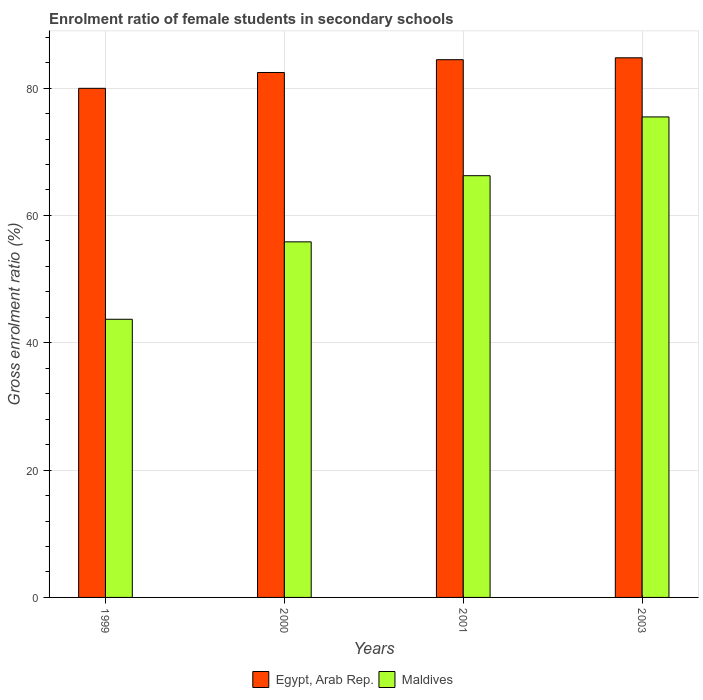How many bars are there on the 2nd tick from the left?
Give a very brief answer. 2. How many bars are there on the 3rd tick from the right?
Give a very brief answer. 2. What is the label of the 1st group of bars from the left?
Give a very brief answer. 1999. In how many cases, is the number of bars for a given year not equal to the number of legend labels?
Give a very brief answer. 0. What is the enrolment ratio of female students in secondary schools in Egypt, Arab Rep. in 2003?
Provide a succinct answer. 84.75. Across all years, what is the maximum enrolment ratio of female students in secondary schools in Maldives?
Keep it short and to the point. 75.47. Across all years, what is the minimum enrolment ratio of female students in secondary schools in Maldives?
Offer a terse response. 43.69. In which year was the enrolment ratio of female students in secondary schools in Maldives maximum?
Make the answer very short. 2003. What is the total enrolment ratio of female students in secondary schools in Maldives in the graph?
Offer a very short reply. 241.24. What is the difference between the enrolment ratio of female students in secondary schools in Egypt, Arab Rep. in 1999 and that in 2000?
Your answer should be compact. -2.48. What is the difference between the enrolment ratio of female students in secondary schools in Maldives in 2003 and the enrolment ratio of female students in secondary schools in Egypt, Arab Rep. in 1999?
Provide a short and direct response. -4.49. What is the average enrolment ratio of female students in secondary schools in Egypt, Arab Rep. per year?
Your response must be concise. 82.91. In the year 2003, what is the difference between the enrolment ratio of female students in secondary schools in Egypt, Arab Rep. and enrolment ratio of female students in secondary schools in Maldives?
Your answer should be compact. 9.29. What is the ratio of the enrolment ratio of female students in secondary schools in Egypt, Arab Rep. in 1999 to that in 2001?
Offer a very short reply. 0.95. Is the enrolment ratio of female students in secondary schools in Maldives in 2001 less than that in 2003?
Ensure brevity in your answer.  Yes. Is the difference between the enrolment ratio of female students in secondary schools in Egypt, Arab Rep. in 2000 and 2003 greater than the difference between the enrolment ratio of female students in secondary schools in Maldives in 2000 and 2003?
Keep it short and to the point. Yes. What is the difference between the highest and the second highest enrolment ratio of female students in secondary schools in Egypt, Arab Rep.?
Offer a very short reply. 0.3. What is the difference between the highest and the lowest enrolment ratio of female students in secondary schools in Maldives?
Offer a terse response. 31.78. Is the sum of the enrolment ratio of female students in secondary schools in Egypt, Arab Rep. in 2000 and 2001 greater than the maximum enrolment ratio of female students in secondary schools in Maldives across all years?
Keep it short and to the point. Yes. What does the 1st bar from the left in 1999 represents?
Make the answer very short. Egypt, Arab Rep. What does the 1st bar from the right in 2003 represents?
Provide a succinct answer. Maldives. Are all the bars in the graph horizontal?
Offer a very short reply. No. How many years are there in the graph?
Offer a terse response. 4. What is the difference between two consecutive major ticks on the Y-axis?
Provide a short and direct response. 20. Where does the legend appear in the graph?
Offer a very short reply. Bottom center. How many legend labels are there?
Your response must be concise. 2. How are the legend labels stacked?
Make the answer very short. Horizontal. What is the title of the graph?
Keep it short and to the point. Enrolment ratio of female students in secondary schools. What is the Gross enrolment ratio (%) in Egypt, Arab Rep. in 1999?
Your answer should be very brief. 79.96. What is the Gross enrolment ratio (%) in Maldives in 1999?
Ensure brevity in your answer.  43.69. What is the Gross enrolment ratio (%) in Egypt, Arab Rep. in 2000?
Your answer should be very brief. 82.45. What is the Gross enrolment ratio (%) of Maldives in 2000?
Provide a short and direct response. 55.85. What is the Gross enrolment ratio (%) of Egypt, Arab Rep. in 2001?
Your answer should be very brief. 84.46. What is the Gross enrolment ratio (%) of Maldives in 2001?
Make the answer very short. 66.24. What is the Gross enrolment ratio (%) in Egypt, Arab Rep. in 2003?
Provide a succinct answer. 84.75. What is the Gross enrolment ratio (%) in Maldives in 2003?
Your response must be concise. 75.47. Across all years, what is the maximum Gross enrolment ratio (%) of Egypt, Arab Rep.?
Give a very brief answer. 84.75. Across all years, what is the maximum Gross enrolment ratio (%) of Maldives?
Keep it short and to the point. 75.47. Across all years, what is the minimum Gross enrolment ratio (%) of Egypt, Arab Rep.?
Offer a very short reply. 79.96. Across all years, what is the minimum Gross enrolment ratio (%) in Maldives?
Give a very brief answer. 43.69. What is the total Gross enrolment ratio (%) in Egypt, Arab Rep. in the graph?
Provide a succinct answer. 331.62. What is the total Gross enrolment ratio (%) in Maldives in the graph?
Keep it short and to the point. 241.24. What is the difference between the Gross enrolment ratio (%) in Egypt, Arab Rep. in 1999 and that in 2000?
Your response must be concise. -2.48. What is the difference between the Gross enrolment ratio (%) in Maldives in 1999 and that in 2000?
Offer a very short reply. -12.16. What is the difference between the Gross enrolment ratio (%) in Egypt, Arab Rep. in 1999 and that in 2001?
Give a very brief answer. -4.49. What is the difference between the Gross enrolment ratio (%) of Maldives in 1999 and that in 2001?
Your answer should be compact. -22.55. What is the difference between the Gross enrolment ratio (%) of Egypt, Arab Rep. in 1999 and that in 2003?
Keep it short and to the point. -4.79. What is the difference between the Gross enrolment ratio (%) of Maldives in 1999 and that in 2003?
Your answer should be compact. -31.78. What is the difference between the Gross enrolment ratio (%) in Egypt, Arab Rep. in 2000 and that in 2001?
Your answer should be very brief. -2.01. What is the difference between the Gross enrolment ratio (%) in Maldives in 2000 and that in 2001?
Your response must be concise. -10.39. What is the difference between the Gross enrolment ratio (%) of Egypt, Arab Rep. in 2000 and that in 2003?
Your answer should be compact. -2.31. What is the difference between the Gross enrolment ratio (%) in Maldives in 2000 and that in 2003?
Give a very brief answer. -19.62. What is the difference between the Gross enrolment ratio (%) of Egypt, Arab Rep. in 2001 and that in 2003?
Provide a short and direct response. -0.3. What is the difference between the Gross enrolment ratio (%) of Maldives in 2001 and that in 2003?
Ensure brevity in your answer.  -9.23. What is the difference between the Gross enrolment ratio (%) in Egypt, Arab Rep. in 1999 and the Gross enrolment ratio (%) in Maldives in 2000?
Give a very brief answer. 24.11. What is the difference between the Gross enrolment ratio (%) of Egypt, Arab Rep. in 1999 and the Gross enrolment ratio (%) of Maldives in 2001?
Provide a succinct answer. 13.73. What is the difference between the Gross enrolment ratio (%) of Egypt, Arab Rep. in 1999 and the Gross enrolment ratio (%) of Maldives in 2003?
Offer a terse response. 4.49. What is the difference between the Gross enrolment ratio (%) of Egypt, Arab Rep. in 2000 and the Gross enrolment ratio (%) of Maldives in 2001?
Provide a succinct answer. 16.21. What is the difference between the Gross enrolment ratio (%) of Egypt, Arab Rep. in 2000 and the Gross enrolment ratio (%) of Maldives in 2003?
Offer a terse response. 6.98. What is the difference between the Gross enrolment ratio (%) of Egypt, Arab Rep. in 2001 and the Gross enrolment ratio (%) of Maldives in 2003?
Ensure brevity in your answer.  8.99. What is the average Gross enrolment ratio (%) in Egypt, Arab Rep. per year?
Your response must be concise. 82.91. What is the average Gross enrolment ratio (%) of Maldives per year?
Provide a succinct answer. 60.31. In the year 1999, what is the difference between the Gross enrolment ratio (%) in Egypt, Arab Rep. and Gross enrolment ratio (%) in Maldives?
Offer a terse response. 36.28. In the year 2000, what is the difference between the Gross enrolment ratio (%) in Egypt, Arab Rep. and Gross enrolment ratio (%) in Maldives?
Give a very brief answer. 26.6. In the year 2001, what is the difference between the Gross enrolment ratio (%) of Egypt, Arab Rep. and Gross enrolment ratio (%) of Maldives?
Keep it short and to the point. 18.22. In the year 2003, what is the difference between the Gross enrolment ratio (%) in Egypt, Arab Rep. and Gross enrolment ratio (%) in Maldives?
Keep it short and to the point. 9.29. What is the ratio of the Gross enrolment ratio (%) in Egypt, Arab Rep. in 1999 to that in 2000?
Ensure brevity in your answer.  0.97. What is the ratio of the Gross enrolment ratio (%) of Maldives in 1999 to that in 2000?
Make the answer very short. 0.78. What is the ratio of the Gross enrolment ratio (%) in Egypt, Arab Rep. in 1999 to that in 2001?
Offer a very short reply. 0.95. What is the ratio of the Gross enrolment ratio (%) in Maldives in 1999 to that in 2001?
Make the answer very short. 0.66. What is the ratio of the Gross enrolment ratio (%) of Egypt, Arab Rep. in 1999 to that in 2003?
Make the answer very short. 0.94. What is the ratio of the Gross enrolment ratio (%) of Maldives in 1999 to that in 2003?
Provide a succinct answer. 0.58. What is the ratio of the Gross enrolment ratio (%) of Egypt, Arab Rep. in 2000 to that in 2001?
Provide a succinct answer. 0.98. What is the ratio of the Gross enrolment ratio (%) of Maldives in 2000 to that in 2001?
Your answer should be very brief. 0.84. What is the ratio of the Gross enrolment ratio (%) in Egypt, Arab Rep. in 2000 to that in 2003?
Ensure brevity in your answer.  0.97. What is the ratio of the Gross enrolment ratio (%) of Maldives in 2000 to that in 2003?
Provide a succinct answer. 0.74. What is the ratio of the Gross enrolment ratio (%) in Egypt, Arab Rep. in 2001 to that in 2003?
Your answer should be compact. 1. What is the ratio of the Gross enrolment ratio (%) of Maldives in 2001 to that in 2003?
Provide a short and direct response. 0.88. What is the difference between the highest and the second highest Gross enrolment ratio (%) in Egypt, Arab Rep.?
Offer a terse response. 0.3. What is the difference between the highest and the second highest Gross enrolment ratio (%) in Maldives?
Your answer should be very brief. 9.23. What is the difference between the highest and the lowest Gross enrolment ratio (%) of Egypt, Arab Rep.?
Ensure brevity in your answer.  4.79. What is the difference between the highest and the lowest Gross enrolment ratio (%) in Maldives?
Offer a very short reply. 31.78. 